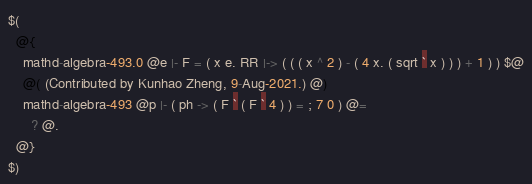<code> <loc_0><loc_0><loc_500><loc_500><_ObjectiveC_>$(
  @{
    mathd-algebra-493.0 @e |- F = ( x e. RR |-> ( ( ( x ^ 2 ) - ( 4 x. ( sqrt ` x ) ) ) + 1 ) ) $@
    @( (Contributed by Kunhao Zheng, 9-Aug-2021.) @)
    mathd-algebra-493 @p |- ( ph -> ( F ` ( F ` 4 ) ) = ; 7 0 ) @=
      ? @.
  @}
$)
</code> 